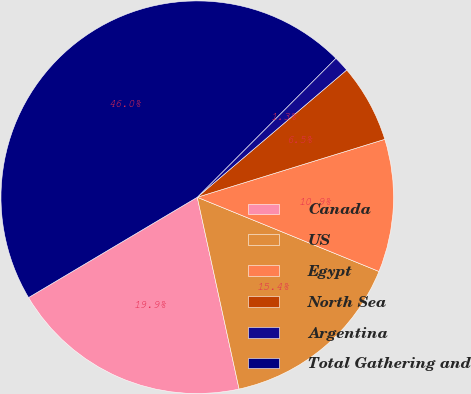Convert chart. <chart><loc_0><loc_0><loc_500><loc_500><pie_chart><fcel>Canada<fcel>US<fcel>Egypt<fcel>North Sea<fcel>Argentina<fcel>Total Gathering and<nl><fcel>19.88%<fcel>15.41%<fcel>10.94%<fcel>6.46%<fcel>1.29%<fcel>46.02%<nl></chart> 